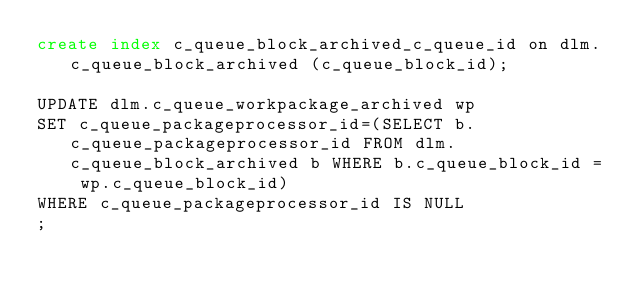<code> <loc_0><loc_0><loc_500><loc_500><_SQL_>create index c_queue_block_archived_c_queue_id on dlm.c_queue_block_archived (c_queue_block_id);

UPDATE dlm.c_queue_workpackage_archived wp
SET c_queue_packageprocessor_id=(SELECT b.c_queue_packageprocessor_id FROM dlm.c_queue_block_archived b WHERE b.c_queue_block_id = wp.c_queue_block_id)
WHERE c_queue_packageprocessor_id IS NULL
;</code> 